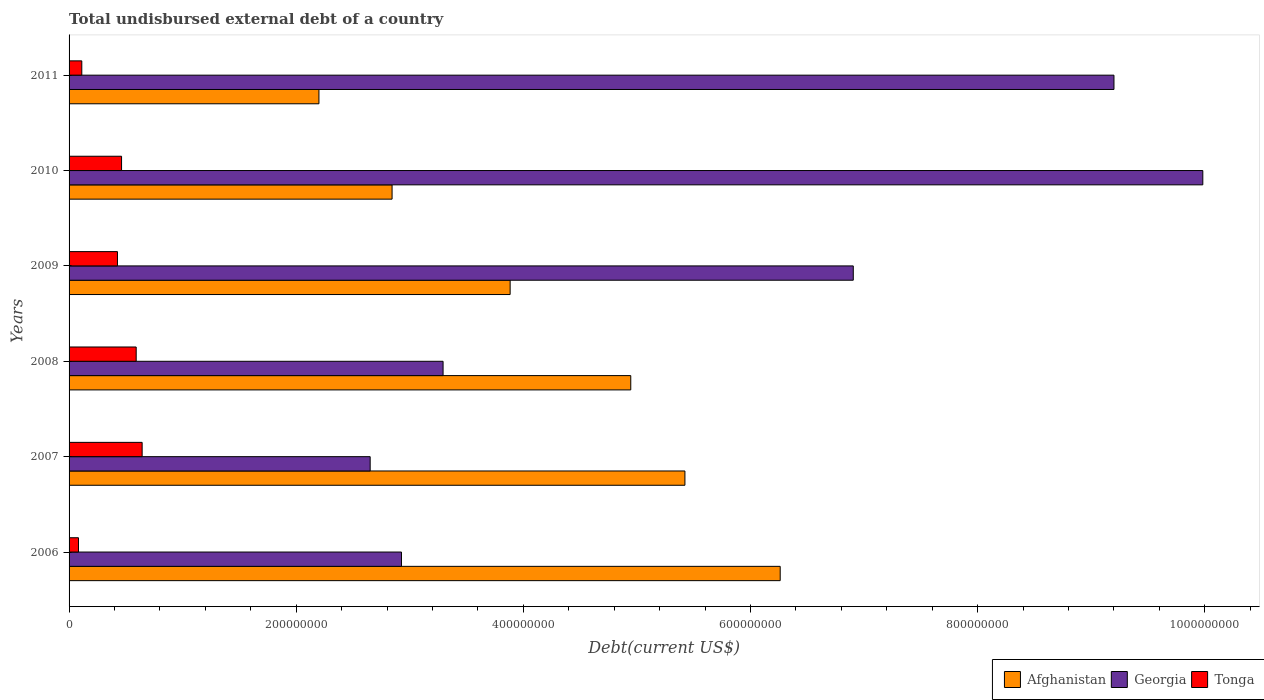How many groups of bars are there?
Your answer should be very brief. 6. Are the number of bars per tick equal to the number of legend labels?
Keep it short and to the point. Yes. Are the number of bars on each tick of the Y-axis equal?
Give a very brief answer. Yes. How many bars are there on the 4th tick from the top?
Keep it short and to the point. 3. What is the label of the 5th group of bars from the top?
Offer a very short reply. 2007. What is the total undisbursed external debt in Georgia in 2007?
Provide a succinct answer. 2.65e+08. Across all years, what is the maximum total undisbursed external debt in Georgia?
Offer a terse response. 9.98e+08. Across all years, what is the minimum total undisbursed external debt in Tonga?
Make the answer very short. 8.28e+06. What is the total total undisbursed external debt in Georgia in the graph?
Make the answer very short. 3.50e+09. What is the difference between the total undisbursed external debt in Tonga in 2007 and that in 2008?
Give a very brief answer. 5.24e+06. What is the difference between the total undisbursed external debt in Afghanistan in 2010 and the total undisbursed external debt in Tonga in 2006?
Your answer should be very brief. 2.76e+08. What is the average total undisbursed external debt in Georgia per year?
Make the answer very short. 5.83e+08. In the year 2007, what is the difference between the total undisbursed external debt in Georgia and total undisbursed external debt in Tonga?
Ensure brevity in your answer.  2.01e+08. What is the ratio of the total undisbursed external debt in Tonga in 2006 to that in 2008?
Your answer should be very brief. 0.14. Is the difference between the total undisbursed external debt in Georgia in 2008 and 2011 greater than the difference between the total undisbursed external debt in Tonga in 2008 and 2011?
Provide a succinct answer. No. What is the difference between the highest and the second highest total undisbursed external debt in Afghanistan?
Your answer should be compact. 8.39e+07. What is the difference between the highest and the lowest total undisbursed external debt in Afghanistan?
Keep it short and to the point. 4.06e+08. What does the 1st bar from the top in 2009 represents?
Your response must be concise. Tonga. What does the 2nd bar from the bottom in 2010 represents?
Ensure brevity in your answer.  Georgia. Is it the case that in every year, the sum of the total undisbursed external debt in Tonga and total undisbursed external debt in Afghanistan is greater than the total undisbursed external debt in Georgia?
Give a very brief answer. No. How many years are there in the graph?
Ensure brevity in your answer.  6. Are the values on the major ticks of X-axis written in scientific E-notation?
Your answer should be very brief. No. Where does the legend appear in the graph?
Offer a very short reply. Bottom right. What is the title of the graph?
Give a very brief answer. Total undisbursed external debt of a country. Does "Sri Lanka" appear as one of the legend labels in the graph?
Your answer should be very brief. No. What is the label or title of the X-axis?
Keep it short and to the point. Debt(current US$). What is the Debt(current US$) of Afghanistan in 2006?
Give a very brief answer. 6.26e+08. What is the Debt(current US$) in Georgia in 2006?
Provide a short and direct response. 2.93e+08. What is the Debt(current US$) of Tonga in 2006?
Provide a succinct answer. 8.28e+06. What is the Debt(current US$) in Afghanistan in 2007?
Offer a very short reply. 5.42e+08. What is the Debt(current US$) of Georgia in 2007?
Offer a very short reply. 2.65e+08. What is the Debt(current US$) of Tonga in 2007?
Ensure brevity in your answer.  6.43e+07. What is the Debt(current US$) in Afghanistan in 2008?
Keep it short and to the point. 4.95e+08. What is the Debt(current US$) of Georgia in 2008?
Your answer should be very brief. 3.29e+08. What is the Debt(current US$) in Tonga in 2008?
Provide a succinct answer. 5.91e+07. What is the Debt(current US$) in Afghanistan in 2009?
Ensure brevity in your answer.  3.88e+08. What is the Debt(current US$) in Georgia in 2009?
Your answer should be compact. 6.90e+08. What is the Debt(current US$) in Tonga in 2009?
Your answer should be very brief. 4.26e+07. What is the Debt(current US$) in Afghanistan in 2010?
Provide a short and direct response. 2.84e+08. What is the Debt(current US$) in Georgia in 2010?
Your response must be concise. 9.98e+08. What is the Debt(current US$) of Tonga in 2010?
Ensure brevity in your answer.  4.62e+07. What is the Debt(current US$) in Afghanistan in 2011?
Your response must be concise. 2.20e+08. What is the Debt(current US$) of Georgia in 2011?
Offer a terse response. 9.20e+08. What is the Debt(current US$) of Tonga in 2011?
Give a very brief answer. 1.12e+07. Across all years, what is the maximum Debt(current US$) in Afghanistan?
Make the answer very short. 6.26e+08. Across all years, what is the maximum Debt(current US$) in Georgia?
Offer a terse response. 9.98e+08. Across all years, what is the maximum Debt(current US$) in Tonga?
Provide a succinct answer. 6.43e+07. Across all years, what is the minimum Debt(current US$) of Afghanistan?
Keep it short and to the point. 2.20e+08. Across all years, what is the minimum Debt(current US$) in Georgia?
Provide a short and direct response. 2.65e+08. Across all years, what is the minimum Debt(current US$) in Tonga?
Offer a terse response. 8.28e+06. What is the total Debt(current US$) of Afghanistan in the graph?
Offer a very short reply. 2.56e+09. What is the total Debt(current US$) of Georgia in the graph?
Provide a short and direct response. 3.50e+09. What is the total Debt(current US$) of Tonga in the graph?
Offer a terse response. 2.32e+08. What is the difference between the Debt(current US$) in Afghanistan in 2006 and that in 2007?
Keep it short and to the point. 8.39e+07. What is the difference between the Debt(current US$) in Georgia in 2006 and that in 2007?
Ensure brevity in your answer.  2.76e+07. What is the difference between the Debt(current US$) of Tonga in 2006 and that in 2007?
Offer a terse response. -5.61e+07. What is the difference between the Debt(current US$) of Afghanistan in 2006 and that in 2008?
Make the answer very short. 1.32e+08. What is the difference between the Debt(current US$) of Georgia in 2006 and that in 2008?
Give a very brief answer. -3.66e+07. What is the difference between the Debt(current US$) of Tonga in 2006 and that in 2008?
Keep it short and to the point. -5.08e+07. What is the difference between the Debt(current US$) of Afghanistan in 2006 and that in 2009?
Provide a short and direct response. 2.38e+08. What is the difference between the Debt(current US$) of Georgia in 2006 and that in 2009?
Make the answer very short. -3.98e+08. What is the difference between the Debt(current US$) of Tonga in 2006 and that in 2009?
Your response must be concise. -3.43e+07. What is the difference between the Debt(current US$) of Afghanistan in 2006 and that in 2010?
Provide a short and direct response. 3.42e+08. What is the difference between the Debt(current US$) in Georgia in 2006 and that in 2010?
Offer a terse response. -7.06e+08. What is the difference between the Debt(current US$) of Tonga in 2006 and that in 2010?
Your answer should be compact. -3.79e+07. What is the difference between the Debt(current US$) of Afghanistan in 2006 and that in 2011?
Provide a short and direct response. 4.06e+08. What is the difference between the Debt(current US$) in Georgia in 2006 and that in 2011?
Your answer should be compact. -6.27e+08. What is the difference between the Debt(current US$) in Tonga in 2006 and that in 2011?
Provide a succinct answer. -2.92e+06. What is the difference between the Debt(current US$) in Afghanistan in 2007 and that in 2008?
Provide a succinct answer. 4.77e+07. What is the difference between the Debt(current US$) of Georgia in 2007 and that in 2008?
Make the answer very short. -6.42e+07. What is the difference between the Debt(current US$) of Tonga in 2007 and that in 2008?
Keep it short and to the point. 5.24e+06. What is the difference between the Debt(current US$) in Afghanistan in 2007 and that in 2009?
Ensure brevity in your answer.  1.54e+08. What is the difference between the Debt(current US$) of Georgia in 2007 and that in 2009?
Offer a very short reply. -4.25e+08. What is the difference between the Debt(current US$) in Tonga in 2007 and that in 2009?
Your answer should be very brief. 2.17e+07. What is the difference between the Debt(current US$) in Afghanistan in 2007 and that in 2010?
Offer a very short reply. 2.58e+08. What is the difference between the Debt(current US$) in Georgia in 2007 and that in 2010?
Your answer should be very brief. -7.33e+08. What is the difference between the Debt(current US$) of Tonga in 2007 and that in 2010?
Ensure brevity in your answer.  1.81e+07. What is the difference between the Debt(current US$) of Afghanistan in 2007 and that in 2011?
Give a very brief answer. 3.22e+08. What is the difference between the Debt(current US$) in Georgia in 2007 and that in 2011?
Your answer should be very brief. -6.55e+08. What is the difference between the Debt(current US$) of Tonga in 2007 and that in 2011?
Keep it short and to the point. 5.31e+07. What is the difference between the Debt(current US$) in Afghanistan in 2008 and that in 2009?
Your answer should be very brief. 1.06e+08. What is the difference between the Debt(current US$) in Georgia in 2008 and that in 2009?
Keep it short and to the point. -3.61e+08. What is the difference between the Debt(current US$) of Tonga in 2008 and that in 2009?
Offer a very short reply. 1.65e+07. What is the difference between the Debt(current US$) of Afghanistan in 2008 and that in 2010?
Your response must be concise. 2.10e+08. What is the difference between the Debt(current US$) in Georgia in 2008 and that in 2010?
Your response must be concise. -6.69e+08. What is the difference between the Debt(current US$) in Tonga in 2008 and that in 2010?
Ensure brevity in your answer.  1.29e+07. What is the difference between the Debt(current US$) of Afghanistan in 2008 and that in 2011?
Offer a very short reply. 2.75e+08. What is the difference between the Debt(current US$) of Georgia in 2008 and that in 2011?
Ensure brevity in your answer.  -5.91e+08. What is the difference between the Debt(current US$) of Tonga in 2008 and that in 2011?
Make the answer very short. 4.79e+07. What is the difference between the Debt(current US$) in Afghanistan in 2009 and that in 2010?
Offer a terse response. 1.04e+08. What is the difference between the Debt(current US$) of Georgia in 2009 and that in 2010?
Give a very brief answer. -3.08e+08. What is the difference between the Debt(current US$) of Tonga in 2009 and that in 2010?
Offer a very short reply. -3.60e+06. What is the difference between the Debt(current US$) of Afghanistan in 2009 and that in 2011?
Give a very brief answer. 1.68e+08. What is the difference between the Debt(current US$) of Georgia in 2009 and that in 2011?
Make the answer very short. -2.30e+08. What is the difference between the Debt(current US$) of Tonga in 2009 and that in 2011?
Provide a succinct answer. 3.14e+07. What is the difference between the Debt(current US$) in Afghanistan in 2010 and that in 2011?
Offer a very short reply. 6.44e+07. What is the difference between the Debt(current US$) in Georgia in 2010 and that in 2011?
Give a very brief answer. 7.82e+07. What is the difference between the Debt(current US$) in Tonga in 2010 and that in 2011?
Make the answer very short. 3.50e+07. What is the difference between the Debt(current US$) in Afghanistan in 2006 and the Debt(current US$) in Georgia in 2007?
Offer a terse response. 3.61e+08. What is the difference between the Debt(current US$) of Afghanistan in 2006 and the Debt(current US$) of Tonga in 2007?
Your answer should be compact. 5.62e+08. What is the difference between the Debt(current US$) in Georgia in 2006 and the Debt(current US$) in Tonga in 2007?
Ensure brevity in your answer.  2.28e+08. What is the difference between the Debt(current US$) of Afghanistan in 2006 and the Debt(current US$) of Georgia in 2008?
Your answer should be compact. 2.97e+08. What is the difference between the Debt(current US$) of Afghanistan in 2006 and the Debt(current US$) of Tonga in 2008?
Offer a very short reply. 5.67e+08. What is the difference between the Debt(current US$) in Georgia in 2006 and the Debt(current US$) in Tonga in 2008?
Your response must be concise. 2.34e+08. What is the difference between the Debt(current US$) of Afghanistan in 2006 and the Debt(current US$) of Georgia in 2009?
Your response must be concise. -6.43e+07. What is the difference between the Debt(current US$) in Afghanistan in 2006 and the Debt(current US$) in Tonga in 2009?
Your response must be concise. 5.84e+08. What is the difference between the Debt(current US$) in Georgia in 2006 and the Debt(current US$) in Tonga in 2009?
Your answer should be very brief. 2.50e+08. What is the difference between the Debt(current US$) in Afghanistan in 2006 and the Debt(current US$) in Georgia in 2010?
Provide a short and direct response. -3.72e+08. What is the difference between the Debt(current US$) in Afghanistan in 2006 and the Debt(current US$) in Tonga in 2010?
Offer a terse response. 5.80e+08. What is the difference between the Debt(current US$) in Georgia in 2006 and the Debt(current US$) in Tonga in 2010?
Your response must be concise. 2.46e+08. What is the difference between the Debt(current US$) in Afghanistan in 2006 and the Debt(current US$) in Georgia in 2011?
Keep it short and to the point. -2.94e+08. What is the difference between the Debt(current US$) of Afghanistan in 2006 and the Debt(current US$) of Tonga in 2011?
Provide a succinct answer. 6.15e+08. What is the difference between the Debt(current US$) in Georgia in 2006 and the Debt(current US$) in Tonga in 2011?
Offer a terse response. 2.81e+08. What is the difference between the Debt(current US$) of Afghanistan in 2007 and the Debt(current US$) of Georgia in 2008?
Keep it short and to the point. 2.13e+08. What is the difference between the Debt(current US$) in Afghanistan in 2007 and the Debt(current US$) in Tonga in 2008?
Your answer should be very brief. 4.83e+08. What is the difference between the Debt(current US$) in Georgia in 2007 and the Debt(current US$) in Tonga in 2008?
Offer a very short reply. 2.06e+08. What is the difference between the Debt(current US$) in Afghanistan in 2007 and the Debt(current US$) in Georgia in 2009?
Your response must be concise. -1.48e+08. What is the difference between the Debt(current US$) of Afghanistan in 2007 and the Debt(current US$) of Tonga in 2009?
Provide a succinct answer. 5.00e+08. What is the difference between the Debt(current US$) in Georgia in 2007 and the Debt(current US$) in Tonga in 2009?
Provide a short and direct response. 2.23e+08. What is the difference between the Debt(current US$) in Afghanistan in 2007 and the Debt(current US$) in Georgia in 2010?
Ensure brevity in your answer.  -4.56e+08. What is the difference between the Debt(current US$) in Afghanistan in 2007 and the Debt(current US$) in Tonga in 2010?
Keep it short and to the point. 4.96e+08. What is the difference between the Debt(current US$) in Georgia in 2007 and the Debt(current US$) in Tonga in 2010?
Keep it short and to the point. 2.19e+08. What is the difference between the Debt(current US$) of Afghanistan in 2007 and the Debt(current US$) of Georgia in 2011?
Keep it short and to the point. -3.78e+08. What is the difference between the Debt(current US$) in Afghanistan in 2007 and the Debt(current US$) in Tonga in 2011?
Ensure brevity in your answer.  5.31e+08. What is the difference between the Debt(current US$) of Georgia in 2007 and the Debt(current US$) of Tonga in 2011?
Keep it short and to the point. 2.54e+08. What is the difference between the Debt(current US$) of Afghanistan in 2008 and the Debt(current US$) of Georgia in 2009?
Provide a short and direct response. -1.96e+08. What is the difference between the Debt(current US$) of Afghanistan in 2008 and the Debt(current US$) of Tonga in 2009?
Make the answer very short. 4.52e+08. What is the difference between the Debt(current US$) of Georgia in 2008 and the Debt(current US$) of Tonga in 2009?
Ensure brevity in your answer.  2.87e+08. What is the difference between the Debt(current US$) of Afghanistan in 2008 and the Debt(current US$) of Georgia in 2010?
Offer a terse response. -5.04e+08. What is the difference between the Debt(current US$) in Afghanistan in 2008 and the Debt(current US$) in Tonga in 2010?
Your answer should be very brief. 4.48e+08. What is the difference between the Debt(current US$) in Georgia in 2008 and the Debt(current US$) in Tonga in 2010?
Ensure brevity in your answer.  2.83e+08. What is the difference between the Debt(current US$) of Afghanistan in 2008 and the Debt(current US$) of Georgia in 2011?
Keep it short and to the point. -4.25e+08. What is the difference between the Debt(current US$) in Afghanistan in 2008 and the Debt(current US$) in Tonga in 2011?
Give a very brief answer. 4.83e+08. What is the difference between the Debt(current US$) in Georgia in 2008 and the Debt(current US$) in Tonga in 2011?
Your answer should be compact. 3.18e+08. What is the difference between the Debt(current US$) of Afghanistan in 2009 and the Debt(current US$) of Georgia in 2010?
Provide a succinct answer. -6.10e+08. What is the difference between the Debt(current US$) of Afghanistan in 2009 and the Debt(current US$) of Tonga in 2010?
Offer a terse response. 3.42e+08. What is the difference between the Debt(current US$) in Georgia in 2009 and the Debt(current US$) in Tonga in 2010?
Provide a short and direct response. 6.44e+08. What is the difference between the Debt(current US$) in Afghanistan in 2009 and the Debt(current US$) in Georgia in 2011?
Offer a terse response. -5.32e+08. What is the difference between the Debt(current US$) in Afghanistan in 2009 and the Debt(current US$) in Tonga in 2011?
Offer a terse response. 3.77e+08. What is the difference between the Debt(current US$) in Georgia in 2009 and the Debt(current US$) in Tonga in 2011?
Your answer should be compact. 6.79e+08. What is the difference between the Debt(current US$) of Afghanistan in 2010 and the Debt(current US$) of Georgia in 2011?
Your answer should be compact. -6.36e+08. What is the difference between the Debt(current US$) in Afghanistan in 2010 and the Debt(current US$) in Tonga in 2011?
Your answer should be very brief. 2.73e+08. What is the difference between the Debt(current US$) in Georgia in 2010 and the Debt(current US$) in Tonga in 2011?
Keep it short and to the point. 9.87e+08. What is the average Debt(current US$) of Afghanistan per year?
Offer a very short reply. 4.26e+08. What is the average Debt(current US$) of Georgia per year?
Provide a succinct answer. 5.83e+08. What is the average Debt(current US$) in Tonga per year?
Provide a short and direct response. 3.86e+07. In the year 2006, what is the difference between the Debt(current US$) of Afghanistan and Debt(current US$) of Georgia?
Make the answer very short. 3.33e+08. In the year 2006, what is the difference between the Debt(current US$) in Afghanistan and Debt(current US$) in Tonga?
Your answer should be compact. 6.18e+08. In the year 2006, what is the difference between the Debt(current US$) of Georgia and Debt(current US$) of Tonga?
Provide a short and direct response. 2.84e+08. In the year 2007, what is the difference between the Debt(current US$) of Afghanistan and Debt(current US$) of Georgia?
Your response must be concise. 2.77e+08. In the year 2007, what is the difference between the Debt(current US$) of Afghanistan and Debt(current US$) of Tonga?
Keep it short and to the point. 4.78e+08. In the year 2007, what is the difference between the Debt(current US$) of Georgia and Debt(current US$) of Tonga?
Provide a short and direct response. 2.01e+08. In the year 2008, what is the difference between the Debt(current US$) of Afghanistan and Debt(current US$) of Georgia?
Offer a very short reply. 1.65e+08. In the year 2008, what is the difference between the Debt(current US$) of Afghanistan and Debt(current US$) of Tonga?
Provide a short and direct response. 4.35e+08. In the year 2008, what is the difference between the Debt(current US$) of Georgia and Debt(current US$) of Tonga?
Offer a very short reply. 2.70e+08. In the year 2009, what is the difference between the Debt(current US$) in Afghanistan and Debt(current US$) in Georgia?
Ensure brevity in your answer.  -3.02e+08. In the year 2009, what is the difference between the Debt(current US$) of Afghanistan and Debt(current US$) of Tonga?
Make the answer very short. 3.46e+08. In the year 2009, what is the difference between the Debt(current US$) of Georgia and Debt(current US$) of Tonga?
Provide a short and direct response. 6.48e+08. In the year 2010, what is the difference between the Debt(current US$) in Afghanistan and Debt(current US$) in Georgia?
Your answer should be compact. -7.14e+08. In the year 2010, what is the difference between the Debt(current US$) of Afghanistan and Debt(current US$) of Tonga?
Your answer should be compact. 2.38e+08. In the year 2010, what is the difference between the Debt(current US$) in Georgia and Debt(current US$) in Tonga?
Offer a very short reply. 9.52e+08. In the year 2011, what is the difference between the Debt(current US$) in Afghanistan and Debt(current US$) in Georgia?
Your answer should be very brief. -7.00e+08. In the year 2011, what is the difference between the Debt(current US$) of Afghanistan and Debt(current US$) of Tonga?
Provide a short and direct response. 2.09e+08. In the year 2011, what is the difference between the Debt(current US$) in Georgia and Debt(current US$) in Tonga?
Provide a short and direct response. 9.09e+08. What is the ratio of the Debt(current US$) of Afghanistan in 2006 to that in 2007?
Keep it short and to the point. 1.15. What is the ratio of the Debt(current US$) of Georgia in 2006 to that in 2007?
Your answer should be very brief. 1.1. What is the ratio of the Debt(current US$) in Tonga in 2006 to that in 2007?
Your answer should be very brief. 0.13. What is the ratio of the Debt(current US$) in Afghanistan in 2006 to that in 2008?
Give a very brief answer. 1.27. What is the ratio of the Debt(current US$) in Georgia in 2006 to that in 2008?
Offer a terse response. 0.89. What is the ratio of the Debt(current US$) of Tonga in 2006 to that in 2008?
Your answer should be very brief. 0.14. What is the ratio of the Debt(current US$) of Afghanistan in 2006 to that in 2009?
Offer a very short reply. 1.61. What is the ratio of the Debt(current US$) in Georgia in 2006 to that in 2009?
Offer a very short reply. 0.42. What is the ratio of the Debt(current US$) in Tonga in 2006 to that in 2009?
Offer a terse response. 0.19. What is the ratio of the Debt(current US$) of Afghanistan in 2006 to that in 2010?
Ensure brevity in your answer.  2.2. What is the ratio of the Debt(current US$) in Georgia in 2006 to that in 2010?
Ensure brevity in your answer.  0.29. What is the ratio of the Debt(current US$) of Tonga in 2006 to that in 2010?
Ensure brevity in your answer.  0.18. What is the ratio of the Debt(current US$) of Afghanistan in 2006 to that in 2011?
Your response must be concise. 2.85. What is the ratio of the Debt(current US$) in Georgia in 2006 to that in 2011?
Ensure brevity in your answer.  0.32. What is the ratio of the Debt(current US$) of Tonga in 2006 to that in 2011?
Your answer should be very brief. 0.74. What is the ratio of the Debt(current US$) in Afghanistan in 2007 to that in 2008?
Your answer should be compact. 1.1. What is the ratio of the Debt(current US$) in Georgia in 2007 to that in 2008?
Your response must be concise. 0.81. What is the ratio of the Debt(current US$) in Tonga in 2007 to that in 2008?
Keep it short and to the point. 1.09. What is the ratio of the Debt(current US$) of Afghanistan in 2007 to that in 2009?
Provide a succinct answer. 1.4. What is the ratio of the Debt(current US$) in Georgia in 2007 to that in 2009?
Provide a succinct answer. 0.38. What is the ratio of the Debt(current US$) in Tonga in 2007 to that in 2009?
Your answer should be very brief. 1.51. What is the ratio of the Debt(current US$) in Afghanistan in 2007 to that in 2010?
Offer a terse response. 1.91. What is the ratio of the Debt(current US$) of Georgia in 2007 to that in 2010?
Provide a short and direct response. 0.27. What is the ratio of the Debt(current US$) in Tonga in 2007 to that in 2010?
Make the answer very short. 1.39. What is the ratio of the Debt(current US$) in Afghanistan in 2007 to that in 2011?
Provide a succinct answer. 2.46. What is the ratio of the Debt(current US$) of Georgia in 2007 to that in 2011?
Ensure brevity in your answer.  0.29. What is the ratio of the Debt(current US$) in Tonga in 2007 to that in 2011?
Your answer should be compact. 5.75. What is the ratio of the Debt(current US$) in Afghanistan in 2008 to that in 2009?
Offer a terse response. 1.27. What is the ratio of the Debt(current US$) in Georgia in 2008 to that in 2009?
Provide a short and direct response. 0.48. What is the ratio of the Debt(current US$) of Tonga in 2008 to that in 2009?
Provide a succinct answer. 1.39. What is the ratio of the Debt(current US$) in Afghanistan in 2008 to that in 2010?
Provide a succinct answer. 1.74. What is the ratio of the Debt(current US$) of Georgia in 2008 to that in 2010?
Provide a succinct answer. 0.33. What is the ratio of the Debt(current US$) in Tonga in 2008 to that in 2010?
Offer a very short reply. 1.28. What is the ratio of the Debt(current US$) in Afghanistan in 2008 to that in 2011?
Your answer should be very brief. 2.25. What is the ratio of the Debt(current US$) of Georgia in 2008 to that in 2011?
Your response must be concise. 0.36. What is the ratio of the Debt(current US$) in Tonga in 2008 to that in 2011?
Keep it short and to the point. 5.28. What is the ratio of the Debt(current US$) of Afghanistan in 2009 to that in 2010?
Your answer should be very brief. 1.37. What is the ratio of the Debt(current US$) in Georgia in 2009 to that in 2010?
Ensure brevity in your answer.  0.69. What is the ratio of the Debt(current US$) in Tonga in 2009 to that in 2010?
Your response must be concise. 0.92. What is the ratio of the Debt(current US$) in Afghanistan in 2009 to that in 2011?
Your answer should be very brief. 1.77. What is the ratio of the Debt(current US$) in Georgia in 2009 to that in 2011?
Provide a short and direct response. 0.75. What is the ratio of the Debt(current US$) in Tonga in 2009 to that in 2011?
Give a very brief answer. 3.81. What is the ratio of the Debt(current US$) of Afghanistan in 2010 to that in 2011?
Make the answer very short. 1.29. What is the ratio of the Debt(current US$) of Georgia in 2010 to that in 2011?
Your answer should be very brief. 1.08. What is the ratio of the Debt(current US$) in Tonga in 2010 to that in 2011?
Offer a very short reply. 4.13. What is the difference between the highest and the second highest Debt(current US$) in Afghanistan?
Make the answer very short. 8.39e+07. What is the difference between the highest and the second highest Debt(current US$) of Georgia?
Give a very brief answer. 7.82e+07. What is the difference between the highest and the second highest Debt(current US$) of Tonga?
Your answer should be very brief. 5.24e+06. What is the difference between the highest and the lowest Debt(current US$) of Afghanistan?
Offer a very short reply. 4.06e+08. What is the difference between the highest and the lowest Debt(current US$) of Georgia?
Your response must be concise. 7.33e+08. What is the difference between the highest and the lowest Debt(current US$) of Tonga?
Make the answer very short. 5.61e+07. 